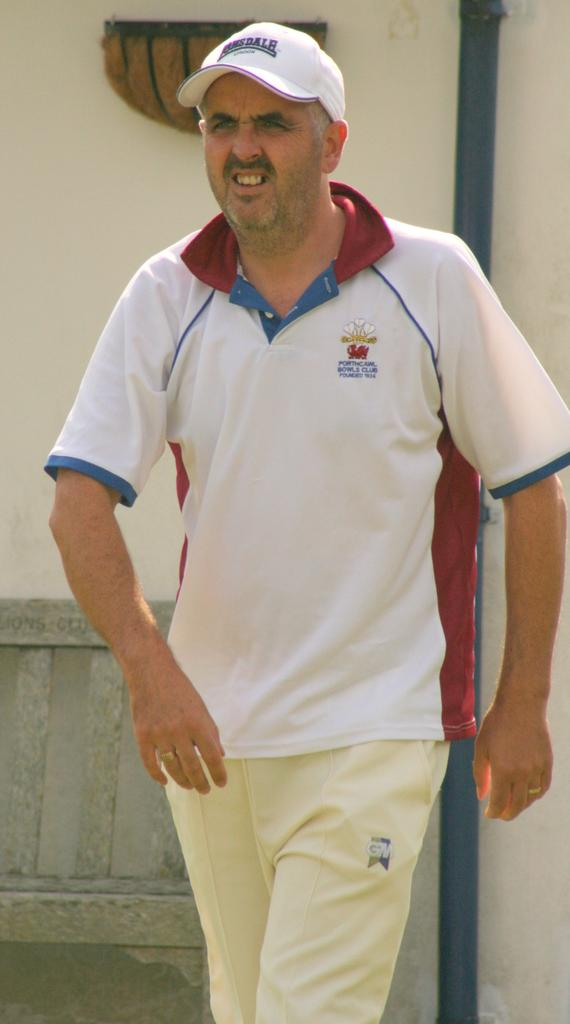What is the main subject of the image? There is a man in the middle of the image. What is the man wearing? The man is wearing a t-shirt, trousers, and a cap. What is the man doing in the image? The man is walking. What can be seen in the background of the image? There is a building, a wall, and a bench in the background of the image. Is there a border between the man and the building in the image? There is no mention of a border in the image; it simply shows a man walking with a building in the background. 